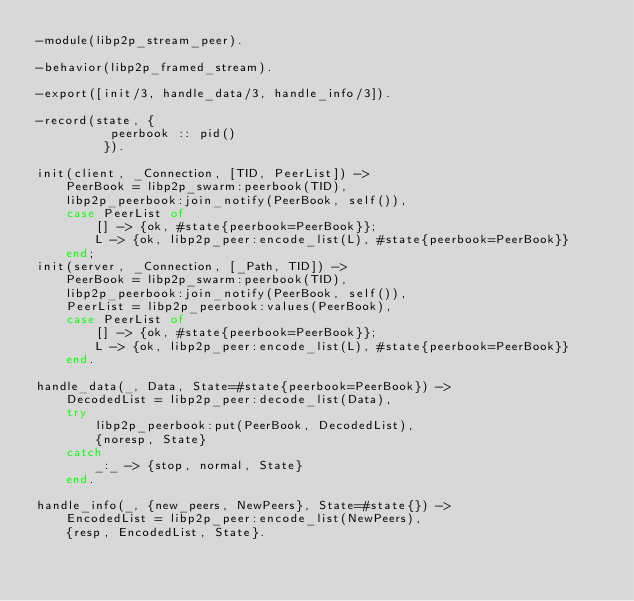<code> <loc_0><loc_0><loc_500><loc_500><_Erlang_>-module(libp2p_stream_peer).

-behavior(libp2p_framed_stream).

-export([init/3, handle_data/3, handle_info/3]).

-record(state, {
          peerbook :: pid()
         }).

init(client, _Connection, [TID, PeerList]) ->
    PeerBook = libp2p_swarm:peerbook(TID),
    libp2p_peerbook:join_notify(PeerBook, self()),
    case PeerList of
        [] -> {ok, #state{peerbook=PeerBook}};
        L -> {ok, libp2p_peer:encode_list(L), #state{peerbook=PeerBook}}
    end;
init(server, _Connection, [_Path, TID]) ->
    PeerBook = libp2p_swarm:peerbook(TID),
    libp2p_peerbook:join_notify(PeerBook, self()),
    PeerList = libp2p_peerbook:values(PeerBook),
    case PeerList of
        [] -> {ok, #state{peerbook=PeerBook}};
        L -> {ok, libp2p_peer:encode_list(L), #state{peerbook=PeerBook}}
    end.

handle_data(_, Data, State=#state{peerbook=PeerBook}) ->
    DecodedList = libp2p_peer:decode_list(Data),
    try
        libp2p_peerbook:put(PeerBook, DecodedList),
        {noresp, State}
    catch
        _:_ -> {stop, normal, State}
    end.

handle_info(_, {new_peers, NewPeers}, State=#state{}) ->
    EncodedList = libp2p_peer:encode_list(NewPeers),
    {resp, EncodedList, State}.
</code> 